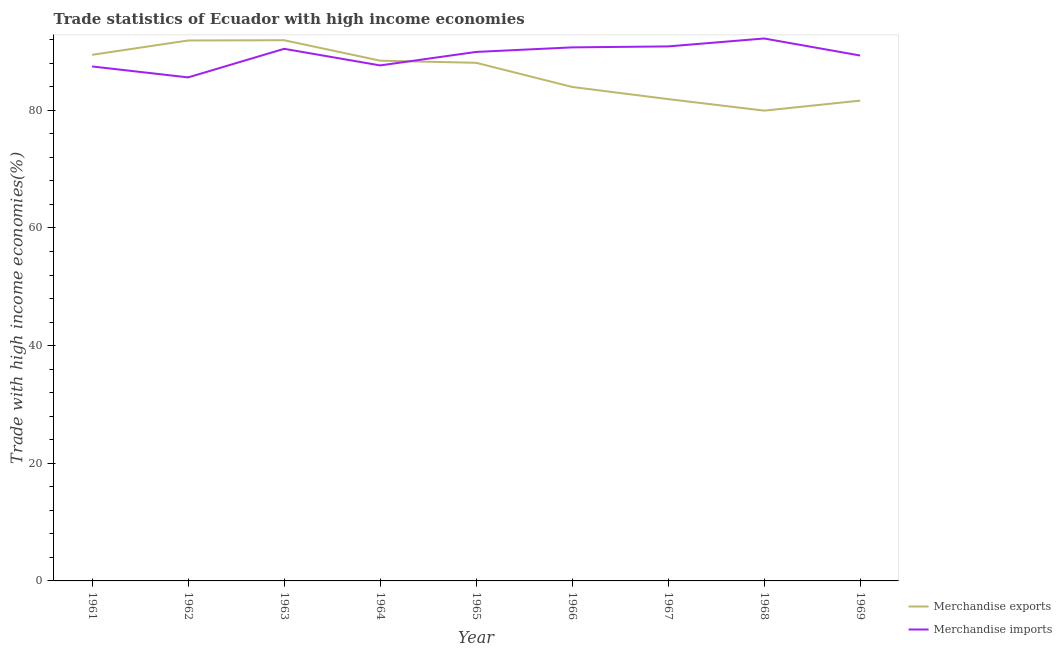Is the number of lines equal to the number of legend labels?
Ensure brevity in your answer.  Yes. What is the merchandise imports in 1962?
Provide a succinct answer. 85.59. Across all years, what is the maximum merchandise exports?
Your answer should be compact. 91.91. Across all years, what is the minimum merchandise imports?
Your response must be concise. 85.59. In which year was the merchandise exports maximum?
Offer a terse response. 1963. In which year was the merchandise imports minimum?
Provide a short and direct response. 1962. What is the total merchandise exports in the graph?
Provide a succinct answer. 777.17. What is the difference between the merchandise imports in 1961 and that in 1965?
Make the answer very short. -2.47. What is the difference between the merchandise imports in 1961 and the merchandise exports in 1968?
Your response must be concise. 7.51. What is the average merchandise exports per year?
Provide a succinct answer. 86.35. In the year 1969, what is the difference between the merchandise exports and merchandise imports?
Offer a very short reply. -7.66. What is the ratio of the merchandise imports in 1962 to that in 1966?
Provide a succinct answer. 0.94. Is the difference between the merchandise imports in 1963 and 1965 greater than the difference between the merchandise exports in 1963 and 1965?
Provide a succinct answer. No. What is the difference between the highest and the second highest merchandise exports?
Make the answer very short. 0.04. What is the difference between the highest and the lowest merchandise imports?
Provide a succinct answer. 6.61. Is the sum of the merchandise imports in 1963 and 1968 greater than the maximum merchandise exports across all years?
Your answer should be very brief. Yes. Is the merchandise imports strictly less than the merchandise exports over the years?
Your answer should be very brief. No. How many lines are there?
Your answer should be compact. 2. What is the difference between two consecutive major ticks on the Y-axis?
Provide a short and direct response. 20. Are the values on the major ticks of Y-axis written in scientific E-notation?
Keep it short and to the point. No. Does the graph contain any zero values?
Provide a short and direct response. No. How are the legend labels stacked?
Provide a short and direct response. Vertical. What is the title of the graph?
Ensure brevity in your answer.  Trade statistics of Ecuador with high income economies. Does "Secondary" appear as one of the legend labels in the graph?
Give a very brief answer. No. What is the label or title of the X-axis?
Offer a very short reply. Year. What is the label or title of the Y-axis?
Keep it short and to the point. Trade with high income economies(%). What is the Trade with high income economies(%) of Merchandise exports in 1961?
Make the answer very short. 89.43. What is the Trade with high income economies(%) in Merchandise imports in 1961?
Make the answer very short. 87.45. What is the Trade with high income economies(%) in Merchandise exports in 1962?
Offer a terse response. 91.87. What is the Trade with high income economies(%) of Merchandise imports in 1962?
Keep it short and to the point. 85.59. What is the Trade with high income economies(%) of Merchandise exports in 1963?
Your response must be concise. 91.91. What is the Trade with high income economies(%) in Merchandise imports in 1963?
Keep it short and to the point. 90.45. What is the Trade with high income economies(%) in Merchandise exports in 1964?
Keep it short and to the point. 88.43. What is the Trade with high income economies(%) in Merchandise imports in 1964?
Your response must be concise. 87.63. What is the Trade with high income economies(%) of Merchandise exports in 1965?
Offer a terse response. 88.07. What is the Trade with high income economies(%) in Merchandise imports in 1965?
Ensure brevity in your answer.  89.92. What is the Trade with high income economies(%) of Merchandise exports in 1966?
Your answer should be very brief. 83.97. What is the Trade with high income economies(%) of Merchandise imports in 1966?
Your answer should be compact. 90.7. What is the Trade with high income economies(%) in Merchandise exports in 1967?
Keep it short and to the point. 81.9. What is the Trade with high income economies(%) in Merchandise imports in 1967?
Offer a terse response. 90.86. What is the Trade with high income economies(%) in Merchandise exports in 1968?
Provide a short and direct response. 79.94. What is the Trade with high income economies(%) of Merchandise imports in 1968?
Provide a succinct answer. 92.21. What is the Trade with high income economies(%) of Merchandise exports in 1969?
Your answer should be very brief. 81.65. What is the Trade with high income economies(%) in Merchandise imports in 1969?
Ensure brevity in your answer.  89.31. Across all years, what is the maximum Trade with high income economies(%) of Merchandise exports?
Offer a very short reply. 91.91. Across all years, what is the maximum Trade with high income economies(%) of Merchandise imports?
Provide a succinct answer. 92.21. Across all years, what is the minimum Trade with high income economies(%) of Merchandise exports?
Give a very brief answer. 79.94. Across all years, what is the minimum Trade with high income economies(%) in Merchandise imports?
Your response must be concise. 85.59. What is the total Trade with high income economies(%) in Merchandise exports in the graph?
Offer a terse response. 777.17. What is the total Trade with high income economies(%) in Merchandise imports in the graph?
Ensure brevity in your answer.  804.12. What is the difference between the Trade with high income economies(%) of Merchandise exports in 1961 and that in 1962?
Your answer should be compact. -2.44. What is the difference between the Trade with high income economies(%) in Merchandise imports in 1961 and that in 1962?
Offer a terse response. 1.86. What is the difference between the Trade with high income economies(%) in Merchandise exports in 1961 and that in 1963?
Your response must be concise. -2.48. What is the difference between the Trade with high income economies(%) of Merchandise imports in 1961 and that in 1963?
Offer a very short reply. -3. What is the difference between the Trade with high income economies(%) of Merchandise imports in 1961 and that in 1964?
Your answer should be very brief. -0.18. What is the difference between the Trade with high income economies(%) of Merchandise exports in 1961 and that in 1965?
Ensure brevity in your answer.  1.36. What is the difference between the Trade with high income economies(%) in Merchandise imports in 1961 and that in 1965?
Offer a terse response. -2.47. What is the difference between the Trade with high income economies(%) in Merchandise exports in 1961 and that in 1966?
Your response must be concise. 5.46. What is the difference between the Trade with high income economies(%) in Merchandise imports in 1961 and that in 1966?
Provide a succinct answer. -3.25. What is the difference between the Trade with high income economies(%) in Merchandise exports in 1961 and that in 1967?
Keep it short and to the point. 7.53. What is the difference between the Trade with high income economies(%) in Merchandise imports in 1961 and that in 1967?
Keep it short and to the point. -3.41. What is the difference between the Trade with high income economies(%) in Merchandise exports in 1961 and that in 1968?
Provide a succinct answer. 9.49. What is the difference between the Trade with high income economies(%) of Merchandise imports in 1961 and that in 1968?
Ensure brevity in your answer.  -4.76. What is the difference between the Trade with high income economies(%) of Merchandise exports in 1961 and that in 1969?
Keep it short and to the point. 7.78. What is the difference between the Trade with high income economies(%) in Merchandise imports in 1961 and that in 1969?
Your response must be concise. -1.86. What is the difference between the Trade with high income economies(%) of Merchandise exports in 1962 and that in 1963?
Make the answer very short. -0.04. What is the difference between the Trade with high income economies(%) in Merchandise imports in 1962 and that in 1963?
Make the answer very short. -4.86. What is the difference between the Trade with high income economies(%) of Merchandise exports in 1962 and that in 1964?
Your answer should be very brief. 3.43. What is the difference between the Trade with high income economies(%) of Merchandise imports in 1962 and that in 1964?
Make the answer very short. -2.04. What is the difference between the Trade with high income economies(%) in Merchandise exports in 1962 and that in 1965?
Give a very brief answer. 3.79. What is the difference between the Trade with high income economies(%) of Merchandise imports in 1962 and that in 1965?
Give a very brief answer. -4.33. What is the difference between the Trade with high income economies(%) of Merchandise exports in 1962 and that in 1966?
Provide a succinct answer. 7.9. What is the difference between the Trade with high income economies(%) in Merchandise imports in 1962 and that in 1966?
Offer a very short reply. -5.1. What is the difference between the Trade with high income economies(%) of Merchandise exports in 1962 and that in 1967?
Make the answer very short. 9.96. What is the difference between the Trade with high income economies(%) in Merchandise imports in 1962 and that in 1967?
Your answer should be compact. -5.27. What is the difference between the Trade with high income economies(%) of Merchandise exports in 1962 and that in 1968?
Offer a terse response. 11.92. What is the difference between the Trade with high income economies(%) of Merchandise imports in 1962 and that in 1968?
Your response must be concise. -6.61. What is the difference between the Trade with high income economies(%) of Merchandise exports in 1962 and that in 1969?
Your answer should be compact. 10.22. What is the difference between the Trade with high income economies(%) in Merchandise imports in 1962 and that in 1969?
Your answer should be very brief. -3.72. What is the difference between the Trade with high income economies(%) in Merchandise exports in 1963 and that in 1964?
Offer a terse response. 3.48. What is the difference between the Trade with high income economies(%) in Merchandise imports in 1963 and that in 1964?
Your answer should be compact. 2.82. What is the difference between the Trade with high income economies(%) in Merchandise exports in 1963 and that in 1965?
Offer a very short reply. 3.84. What is the difference between the Trade with high income economies(%) of Merchandise imports in 1963 and that in 1965?
Your answer should be compact. 0.53. What is the difference between the Trade with high income economies(%) in Merchandise exports in 1963 and that in 1966?
Make the answer very short. 7.94. What is the difference between the Trade with high income economies(%) of Merchandise imports in 1963 and that in 1966?
Offer a very short reply. -0.25. What is the difference between the Trade with high income economies(%) of Merchandise exports in 1963 and that in 1967?
Give a very brief answer. 10.01. What is the difference between the Trade with high income economies(%) of Merchandise imports in 1963 and that in 1967?
Offer a very short reply. -0.41. What is the difference between the Trade with high income economies(%) of Merchandise exports in 1963 and that in 1968?
Your answer should be compact. 11.97. What is the difference between the Trade with high income economies(%) in Merchandise imports in 1963 and that in 1968?
Offer a terse response. -1.76. What is the difference between the Trade with high income economies(%) in Merchandise exports in 1963 and that in 1969?
Keep it short and to the point. 10.27. What is the difference between the Trade with high income economies(%) in Merchandise imports in 1963 and that in 1969?
Ensure brevity in your answer.  1.14. What is the difference between the Trade with high income economies(%) in Merchandise exports in 1964 and that in 1965?
Offer a terse response. 0.36. What is the difference between the Trade with high income economies(%) of Merchandise imports in 1964 and that in 1965?
Ensure brevity in your answer.  -2.29. What is the difference between the Trade with high income economies(%) of Merchandise exports in 1964 and that in 1966?
Provide a succinct answer. 4.47. What is the difference between the Trade with high income economies(%) in Merchandise imports in 1964 and that in 1966?
Give a very brief answer. -3.07. What is the difference between the Trade with high income economies(%) in Merchandise exports in 1964 and that in 1967?
Your answer should be compact. 6.53. What is the difference between the Trade with high income economies(%) of Merchandise imports in 1964 and that in 1967?
Your response must be concise. -3.23. What is the difference between the Trade with high income economies(%) in Merchandise exports in 1964 and that in 1968?
Your answer should be very brief. 8.49. What is the difference between the Trade with high income economies(%) of Merchandise imports in 1964 and that in 1968?
Your response must be concise. -4.58. What is the difference between the Trade with high income economies(%) of Merchandise exports in 1964 and that in 1969?
Ensure brevity in your answer.  6.79. What is the difference between the Trade with high income economies(%) in Merchandise imports in 1964 and that in 1969?
Keep it short and to the point. -1.68. What is the difference between the Trade with high income economies(%) of Merchandise exports in 1965 and that in 1966?
Your response must be concise. 4.11. What is the difference between the Trade with high income economies(%) in Merchandise imports in 1965 and that in 1966?
Your response must be concise. -0.77. What is the difference between the Trade with high income economies(%) in Merchandise exports in 1965 and that in 1967?
Your response must be concise. 6.17. What is the difference between the Trade with high income economies(%) of Merchandise imports in 1965 and that in 1967?
Offer a very short reply. -0.94. What is the difference between the Trade with high income economies(%) in Merchandise exports in 1965 and that in 1968?
Keep it short and to the point. 8.13. What is the difference between the Trade with high income economies(%) of Merchandise imports in 1965 and that in 1968?
Keep it short and to the point. -2.28. What is the difference between the Trade with high income economies(%) of Merchandise exports in 1965 and that in 1969?
Provide a short and direct response. 6.43. What is the difference between the Trade with high income economies(%) in Merchandise imports in 1965 and that in 1969?
Your answer should be compact. 0.61. What is the difference between the Trade with high income economies(%) in Merchandise exports in 1966 and that in 1967?
Give a very brief answer. 2.07. What is the difference between the Trade with high income economies(%) in Merchandise imports in 1966 and that in 1967?
Offer a terse response. -0.16. What is the difference between the Trade with high income economies(%) of Merchandise exports in 1966 and that in 1968?
Your answer should be very brief. 4.03. What is the difference between the Trade with high income economies(%) of Merchandise imports in 1966 and that in 1968?
Your response must be concise. -1.51. What is the difference between the Trade with high income economies(%) in Merchandise exports in 1966 and that in 1969?
Provide a short and direct response. 2.32. What is the difference between the Trade with high income economies(%) of Merchandise imports in 1966 and that in 1969?
Your answer should be very brief. 1.39. What is the difference between the Trade with high income economies(%) of Merchandise exports in 1967 and that in 1968?
Your response must be concise. 1.96. What is the difference between the Trade with high income economies(%) of Merchandise imports in 1967 and that in 1968?
Give a very brief answer. -1.35. What is the difference between the Trade with high income economies(%) of Merchandise exports in 1967 and that in 1969?
Your answer should be very brief. 0.26. What is the difference between the Trade with high income economies(%) in Merchandise imports in 1967 and that in 1969?
Make the answer very short. 1.55. What is the difference between the Trade with high income economies(%) of Merchandise exports in 1968 and that in 1969?
Provide a short and direct response. -1.7. What is the difference between the Trade with high income economies(%) in Merchandise imports in 1968 and that in 1969?
Offer a terse response. 2.9. What is the difference between the Trade with high income economies(%) in Merchandise exports in 1961 and the Trade with high income economies(%) in Merchandise imports in 1962?
Give a very brief answer. 3.84. What is the difference between the Trade with high income economies(%) in Merchandise exports in 1961 and the Trade with high income economies(%) in Merchandise imports in 1963?
Offer a terse response. -1.02. What is the difference between the Trade with high income economies(%) of Merchandise exports in 1961 and the Trade with high income economies(%) of Merchandise imports in 1964?
Your answer should be very brief. 1.8. What is the difference between the Trade with high income economies(%) in Merchandise exports in 1961 and the Trade with high income economies(%) in Merchandise imports in 1965?
Provide a short and direct response. -0.49. What is the difference between the Trade with high income economies(%) in Merchandise exports in 1961 and the Trade with high income economies(%) in Merchandise imports in 1966?
Provide a short and direct response. -1.27. What is the difference between the Trade with high income economies(%) in Merchandise exports in 1961 and the Trade with high income economies(%) in Merchandise imports in 1967?
Offer a terse response. -1.43. What is the difference between the Trade with high income economies(%) in Merchandise exports in 1961 and the Trade with high income economies(%) in Merchandise imports in 1968?
Your response must be concise. -2.78. What is the difference between the Trade with high income economies(%) in Merchandise exports in 1961 and the Trade with high income economies(%) in Merchandise imports in 1969?
Offer a very short reply. 0.12. What is the difference between the Trade with high income economies(%) of Merchandise exports in 1962 and the Trade with high income economies(%) of Merchandise imports in 1963?
Provide a short and direct response. 1.42. What is the difference between the Trade with high income economies(%) in Merchandise exports in 1962 and the Trade with high income economies(%) in Merchandise imports in 1964?
Offer a terse response. 4.24. What is the difference between the Trade with high income economies(%) of Merchandise exports in 1962 and the Trade with high income economies(%) of Merchandise imports in 1965?
Offer a terse response. 1.94. What is the difference between the Trade with high income economies(%) of Merchandise exports in 1962 and the Trade with high income economies(%) of Merchandise imports in 1966?
Provide a succinct answer. 1.17. What is the difference between the Trade with high income economies(%) in Merchandise exports in 1962 and the Trade with high income economies(%) in Merchandise imports in 1967?
Offer a terse response. 1.01. What is the difference between the Trade with high income economies(%) of Merchandise exports in 1962 and the Trade with high income economies(%) of Merchandise imports in 1968?
Offer a very short reply. -0.34. What is the difference between the Trade with high income economies(%) of Merchandise exports in 1962 and the Trade with high income economies(%) of Merchandise imports in 1969?
Your answer should be very brief. 2.56. What is the difference between the Trade with high income economies(%) in Merchandise exports in 1963 and the Trade with high income economies(%) in Merchandise imports in 1964?
Your response must be concise. 4.28. What is the difference between the Trade with high income economies(%) in Merchandise exports in 1963 and the Trade with high income economies(%) in Merchandise imports in 1965?
Offer a very short reply. 1.99. What is the difference between the Trade with high income economies(%) of Merchandise exports in 1963 and the Trade with high income economies(%) of Merchandise imports in 1966?
Offer a very short reply. 1.21. What is the difference between the Trade with high income economies(%) in Merchandise exports in 1963 and the Trade with high income economies(%) in Merchandise imports in 1967?
Offer a terse response. 1.05. What is the difference between the Trade with high income economies(%) of Merchandise exports in 1963 and the Trade with high income economies(%) of Merchandise imports in 1968?
Make the answer very short. -0.3. What is the difference between the Trade with high income economies(%) in Merchandise exports in 1963 and the Trade with high income economies(%) in Merchandise imports in 1969?
Offer a terse response. 2.6. What is the difference between the Trade with high income economies(%) of Merchandise exports in 1964 and the Trade with high income economies(%) of Merchandise imports in 1965?
Offer a terse response. -1.49. What is the difference between the Trade with high income economies(%) in Merchandise exports in 1964 and the Trade with high income economies(%) in Merchandise imports in 1966?
Ensure brevity in your answer.  -2.26. What is the difference between the Trade with high income economies(%) of Merchandise exports in 1964 and the Trade with high income economies(%) of Merchandise imports in 1967?
Your response must be concise. -2.42. What is the difference between the Trade with high income economies(%) in Merchandise exports in 1964 and the Trade with high income economies(%) in Merchandise imports in 1968?
Keep it short and to the point. -3.77. What is the difference between the Trade with high income economies(%) of Merchandise exports in 1964 and the Trade with high income economies(%) of Merchandise imports in 1969?
Offer a terse response. -0.87. What is the difference between the Trade with high income economies(%) in Merchandise exports in 1965 and the Trade with high income economies(%) in Merchandise imports in 1966?
Provide a succinct answer. -2.62. What is the difference between the Trade with high income economies(%) in Merchandise exports in 1965 and the Trade with high income economies(%) in Merchandise imports in 1967?
Your answer should be compact. -2.79. What is the difference between the Trade with high income economies(%) in Merchandise exports in 1965 and the Trade with high income economies(%) in Merchandise imports in 1968?
Provide a succinct answer. -4.13. What is the difference between the Trade with high income economies(%) in Merchandise exports in 1965 and the Trade with high income economies(%) in Merchandise imports in 1969?
Make the answer very short. -1.24. What is the difference between the Trade with high income economies(%) in Merchandise exports in 1966 and the Trade with high income economies(%) in Merchandise imports in 1967?
Keep it short and to the point. -6.89. What is the difference between the Trade with high income economies(%) of Merchandise exports in 1966 and the Trade with high income economies(%) of Merchandise imports in 1968?
Offer a very short reply. -8.24. What is the difference between the Trade with high income economies(%) of Merchandise exports in 1966 and the Trade with high income economies(%) of Merchandise imports in 1969?
Your response must be concise. -5.34. What is the difference between the Trade with high income economies(%) in Merchandise exports in 1967 and the Trade with high income economies(%) in Merchandise imports in 1968?
Provide a succinct answer. -10.3. What is the difference between the Trade with high income economies(%) of Merchandise exports in 1967 and the Trade with high income economies(%) of Merchandise imports in 1969?
Ensure brevity in your answer.  -7.41. What is the difference between the Trade with high income economies(%) of Merchandise exports in 1968 and the Trade with high income economies(%) of Merchandise imports in 1969?
Provide a succinct answer. -9.37. What is the average Trade with high income economies(%) in Merchandise exports per year?
Give a very brief answer. 86.35. What is the average Trade with high income economies(%) of Merchandise imports per year?
Offer a terse response. 89.35. In the year 1961, what is the difference between the Trade with high income economies(%) of Merchandise exports and Trade with high income economies(%) of Merchandise imports?
Your answer should be compact. 1.98. In the year 1962, what is the difference between the Trade with high income economies(%) of Merchandise exports and Trade with high income economies(%) of Merchandise imports?
Ensure brevity in your answer.  6.27. In the year 1963, what is the difference between the Trade with high income economies(%) of Merchandise exports and Trade with high income economies(%) of Merchandise imports?
Offer a very short reply. 1.46. In the year 1964, what is the difference between the Trade with high income economies(%) of Merchandise exports and Trade with high income economies(%) of Merchandise imports?
Give a very brief answer. 0.81. In the year 1965, what is the difference between the Trade with high income economies(%) in Merchandise exports and Trade with high income economies(%) in Merchandise imports?
Provide a succinct answer. -1.85. In the year 1966, what is the difference between the Trade with high income economies(%) in Merchandise exports and Trade with high income economies(%) in Merchandise imports?
Your answer should be very brief. -6.73. In the year 1967, what is the difference between the Trade with high income economies(%) in Merchandise exports and Trade with high income economies(%) in Merchandise imports?
Provide a short and direct response. -8.96. In the year 1968, what is the difference between the Trade with high income economies(%) in Merchandise exports and Trade with high income economies(%) in Merchandise imports?
Keep it short and to the point. -12.26. In the year 1969, what is the difference between the Trade with high income economies(%) of Merchandise exports and Trade with high income economies(%) of Merchandise imports?
Make the answer very short. -7.66. What is the ratio of the Trade with high income economies(%) in Merchandise exports in 1961 to that in 1962?
Provide a short and direct response. 0.97. What is the ratio of the Trade with high income economies(%) of Merchandise imports in 1961 to that in 1962?
Ensure brevity in your answer.  1.02. What is the ratio of the Trade with high income economies(%) in Merchandise exports in 1961 to that in 1963?
Your answer should be compact. 0.97. What is the ratio of the Trade with high income economies(%) of Merchandise imports in 1961 to that in 1963?
Offer a very short reply. 0.97. What is the ratio of the Trade with high income economies(%) in Merchandise exports in 1961 to that in 1964?
Make the answer very short. 1.01. What is the ratio of the Trade with high income economies(%) in Merchandise imports in 1961 to that in 1964?
Provide a succinct answer. 1. What is the ratio of the Trade with high income economies(%) in Merchandise exports in 1961 to that in 1965?
Give a very brief answer. 1.02. What is the ratio of the Trade with high income economies(%) of Merchandise imports in 1961 to that in 1965?
Offer a terse response. 0.97. What is the ratio of the Trade with high income economies(%) of Merchandise exports in 1961 to that in 1966?
Your answer should be very brief. 1.07. What is the ratio of the Trade with high income economies(%) of Merchandise imports in 1961 to that in 1966?
Keep it short and to the point. 0.96. What is the ratio of the Trade with high income economies(%) of Merchandise exports in 1961 to that in 1967?
Ensure brevity in your answer.  1.09. What is the ratio of the Trade with high income economies(%) of Merchandise imports in 1961 to that in 1967?
Give a very brief answer. 0.96. What is the ratio of the Trade with high income economies(%) of Merchandise exports in 1961 to that in 1968?
Keep it short and to the point. 1.12. What is the ratio of the Trade with high income economies(%) in Merchandise imports in 1961 to that in 1968?
Ensure brevity in your answer.  0.95. What is the ratio of the Trade with high income economies(%) in Merchandise exports in 1961 to that in 1969?
Give a very brief answer. 1.1. What is the ratio of the Trade with high income economies(%) of Merchandise imports in 1961 to that in 1969?
Keep it short and to the point. 0.98. What is the ratio of the Trade with high income economies(%) in Merchandise imports in 1962 to that in 1963?
Make the answer very short. 0.95. What is the ratio of the Trade with high income economies(%) in Merchandise exports in 1962 to that in 1964?
Offer a very short reply. 1.04. What is the ratio of the Trade with high income economies(%) of Merchandise imports in 1962 to that in 1964?
Provide a short and direct response. 0.98. What is the ratio of the Trade with high income economies(%) of Merchandise exports in 1962 to that in 1965?
Give a very brief answer. 1.04. What is the ratio of the Trade with high income economies(%) of Merchandise imports in 1962 to that in 1965?
Give a very brief answer. 0.95. What is the ratio of the Trade with high income economies(%) in Merchandise exports in 1962 to that in 1966?
Your answer should be very brief. 1.09. What is the ratio of the Trade with high income economies(%) of Merchandise imports in 1962 to that in 1966?
Your answer should be compact. 0.94. What is the ratio of the Trade with high income economies(%) of Merchandise exports in 1962 to that in 1967?
Your answer should be very brief. 1.12. What is the ratio of the Trade with high income economies(%) in Merchandise imports in 1962 to that in 1967?
Offer a very short reply. 0.94. What is the ratio of the Trade with high income economies(%) of Merchandise exports in 1962 to that in 1968?
Ensure brevity in your answer.  1.15. What is the ratio of the Trade with high income economies(%) in Merchandise imports in 1962 to that in 1968?
Keep it short and to the point. 0.93. What is the ratio of the Trade with high income economies(%) in Merchandise exports in 1962 to that in 1969?
Your response must be concise. 1.13. What is the ratio of the Trade with high income economies(%) of Merchandise imports in 1962 to that in 1969?
Make the answer very short. 0.96. What is the ratio of the Trade with high income economies(%) in Merchandise exports in 1963 to that in 1964?
Your answer should be compact. 1.04. What is the ratio of the Trade with high income economies(%) of Merchandise imports in 1963 to that in 1964?
Your answer should be compact. 1.03. What is the ratio of the Trade with high income economies(%) of Merchandise exports in 1963 to that in 1965?
Your answer should be very brief. 1.04. What is the ratio of the Trade with high income economies(%) of Merchandise imports in 1963 to that in 1965?
Your response must be concise. 1.01. What is the ratio of the Trade with high income economies(%) of Merchandise exports in 1963 to that in 1966?
Your answer should be very brief. 1.09. What is the ratio of the Trade with high income economies(%) of Merchandise imports in 1963 to that in 1966?
Keep it short and to the point. 1. What is the ratio of the Trade with high income economies(%) of Merchandise exports in 1963 to that in 1967?
Your response must be concise. 1.12. What is the ratio of the Trade with high income economies(%) of Merchandise exports in 1963 to that in 1968?
Offer a very short reply. 1.15. What is the ratio of the Trade with high income economies(%) of Merchandise imports in 1963 to that in 1968?
Ensure brevity in your answer.  0.98. What is the ratio of the Trade with high income economies(%) in Merchandise exports in 1963 to that in 1969?
Your response must be concise. 1.13. What is the ratio of the Trade with high income economies(%) of Merchandise imports in 1963 to that in 1969?
Keep it short and to the point. 1.01. What is the ratio of the Trade with high income economies(%) in Merchandise exports in 1964 to that in 1965?
Give a very brief answer. 1. What is the ratio of the Trade with high income economies(%) in Merchandise imports in 1964 to that in 1965?
Give a very brief answer. 0.97. What is the ratio of the Trade with high income economies(%) of Merchandise exports in 1964 to that in 1966?
Provide a succinct answer. 1.05. What is the ratio of the Trade with high income economies(%) in Merchandise imports in 1964 to that in 1966?
Offer a terse response. 0.97. What is the ratio of the Trade with high income economies(%) of Merchandise exports in 1964 to that in 1967?
Your answer should be compact. 1.08. What is the ratio of the Trade with high income economies(%) in Merchandise imports in 1964 to that in 1967?
Ensure brevity in your answer.  0.96. What is the ratio of the Trade with high income economies(%) of Merchandise exports in 1964 to that in 1968?
Your answer should be compact. 1.11. What is the ratio of the Trade with high income economies(%) of Merchandise imports in 1964 to that in 1968?
Your response must be concise. 0.95. What is the ratio of the Trade with high income economies(%) of Merchandise exports in 1964 to that in 1969?
Keep it short and to the point. 1.08. What is the ratio of the Trade with high income economies(%) of Merchandise imports in 1964 to that in 1969?
Ensure brevity in your answer.  0.98. What is the ratio of the Trade with high income economies(%) of Merchandise exports in 1965 to that in 1966?
Provide a succinct answer. 1.05. What is the ratio of the Trade with high income economies(%) of Merchandise exports in 1965 to that in 1967?
Your answer should be very brief. 1.08. What is the ratio of the Trade with high income economies(%) of Merchandise exports in 1965 to that in 1968?
Offer a terse response. 1.1. What is the ratio of the Trade with high income economies(%) of Merchandise imports in 1965 to that in 1968?
Keep it short and to the point. 0.98. What is the ratio of the Trade with high income economies(%) in Merchandise exports in 1965 to that in 1969?
Offer a very short reply. 1.08. What is the ratio of the Trade with high income economies(%) in Merchandise imports in 1965 to that in 1969?
Your response must be concise. 1.01. What is the ratio of the Trade with high income economies(%) of Merchandise exports in 1966 to that in 1967?
Make the answer very short. 1.03. What is the ratio of the Trade with high income economies(%) in Merchandise exports in 1966 to that in 1968?
Your answer should be very brief. 1.05. What is the ratio of the Trade with high income economies(%) in Merchandise imports in 1966 to that in 1968?
Offer a terse response. 0.98. What is the ratio of the Trade with high income economies(%) of Merchandise exports in 1966 to that in 1969?
Provide a succinct answer. 1.03. What is the ratio of the Trade with high income economies(%) in Merchandise imports in 1966 to that in 1969?
Offer a terse response. 1.02. What is the ratio of the Trade with high income economies(%) in Merchandise exports in 1967 to that in 1968?
Keep it short and to the point. 1.02. What is the ratio of the Trade with high income economies(%) in Merchandise imports in 1967 to that in 1968?
Make the answer very short. 0.99. What is the ratio of the Trade with high income economies(%) in Merchandise imports in 1967 to that in 1969?
Give a very brief answer. 1.02. What is the ratio of the Trade with high income economies(%) of Merchandise exports in 1968 to that in 1969?
Your answer should be compact. 0.98. What is the ratio of the Trade with high income economies(%) in Merchandise imports in 1968 to that in 1969?
Give a very brief answer. 1.03. What is the difference between the highest and the second highest Trade with high income economies(%) of Merchandise exports?
Keep it short and to the point. 0.04. What is the difference between the highest and the second highest Trade with high income economies(%) of Merchandise imports?
Provide a succinct answer. 1.35. What is the difference between the highest and the lowest Trade with high income economies(%) of Merchandise exports?
Provide a succinct answer. 11.97. What is the difference between the highest and the lowest Trade with high income economies(%) in Merchandise imports?
Make the answer very short. 6.61. 